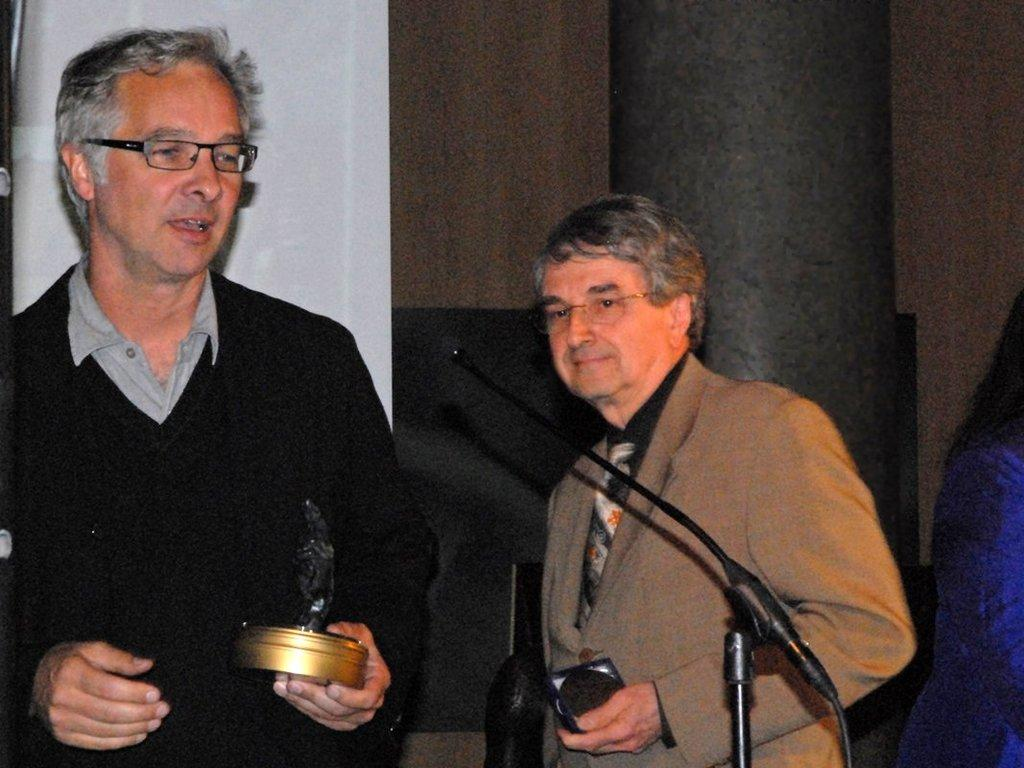How many people are in the image? There are two men standing in the image. What are the men wearing that is visible in the image? The men are wearing glasses (specs) in the image. What object can be seen in the image that is typically used for amplifying sound? There is a black color microphone in the image. What type of toothbrush can be seen in the image? There is no toothbrush present in the image. How many cats are visible in the image? There are no cats visible in the image. 